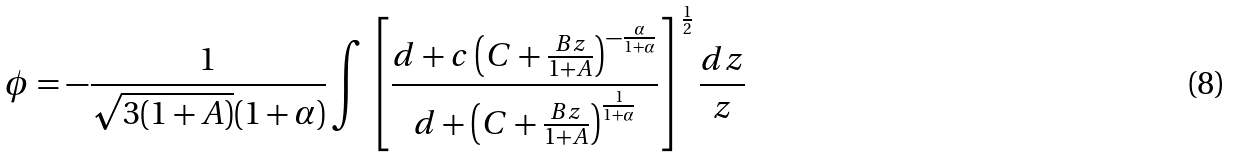Convert formula to latex. <formula><loc_0><loc_0><loc_500><loc_500>\phi = - \frac { 1 } { \sqrt { 3 ( 1 + A ) } ( 1 + \alpha ) } \int \left [ \frac { d + c \left ( C + \frac { B z } { 1 + A } \right ) ^ { - \frac { \alpha } { 1 + \alpha } } } { d + \left ( C + \frac { B z } { 1 + A } \right ) ^ { \frac { 1 } { 1 + \alpha } } } \right ] ^ { \frac { 1 } { 2 } } \frac { d z } { z }</formula> 